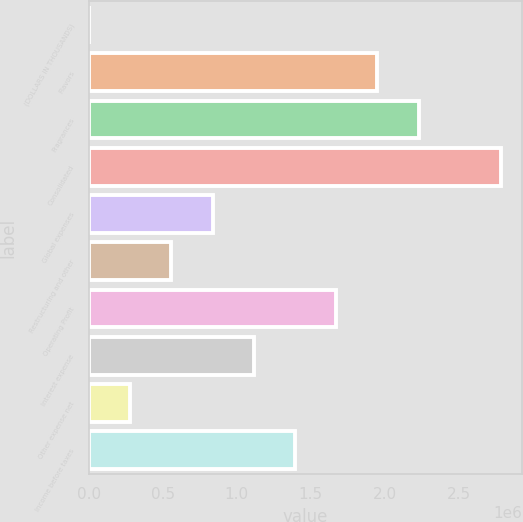Convert chart. <chart><loc_0><loc_0><loc_500><loc_500><bar_chart><fcel>(DOLLARS IN THOUSANDS)<fcel>Flavors<fcel>Fragrances<fcel>Consolidated<fcel>Global expenses<fcel>Restructuring and other<fcel>Operating Profit<fcel>Interest expense<fcel>Other expense net<fcel>Income before taxes<nl><fcel>2011<fcel>1.95222e+06<fcel>2.23082e+06<fcel>2.78802e+06<fcel>837813<fcel>559212<fcel>1.67362e+06<fcel>1.11641e+06<fcel>280612<fcel>1.39501e+06<nl></chart> 